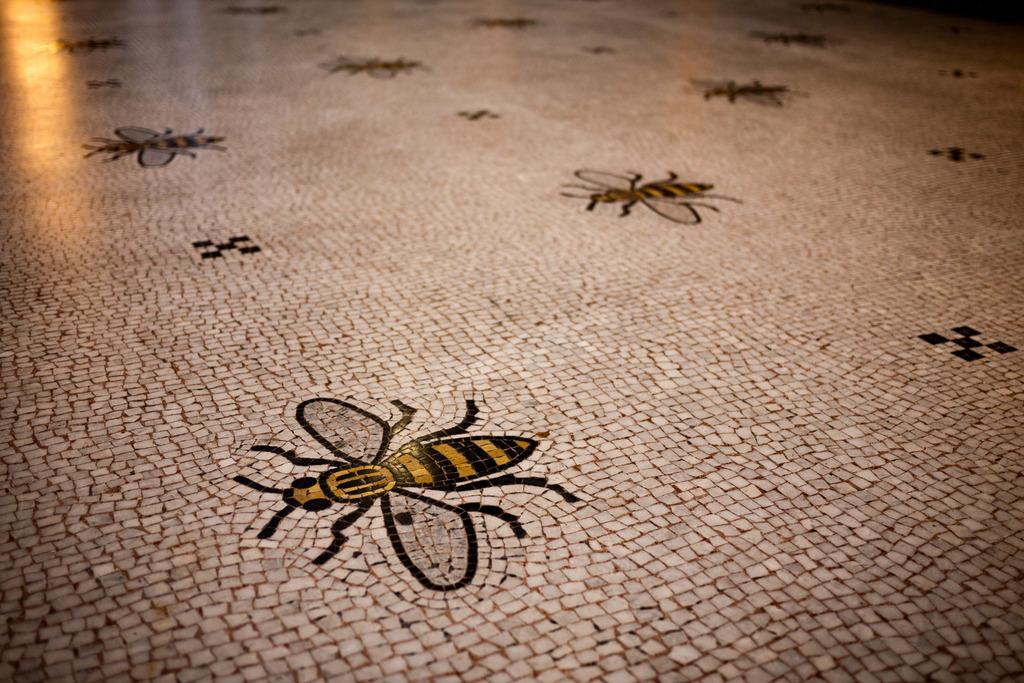What type of creatures are depicted on the floor in the image? There are images of insects on the floor in the image. What type of lipstick is being used by the insects in the image? There are no insects using lipstick in the image, as insects do not use cosmetics. 